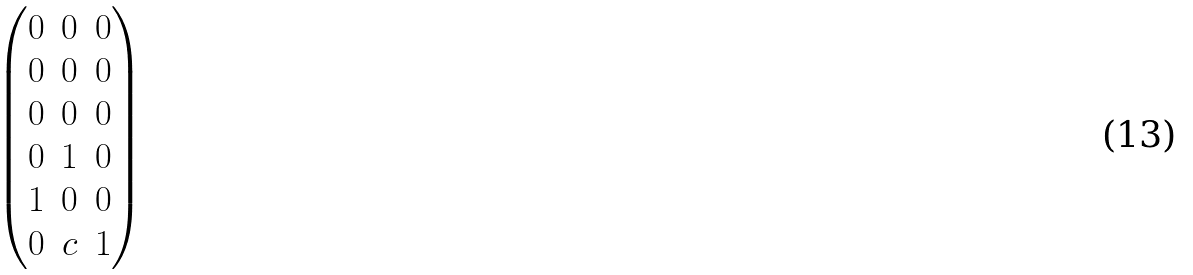<formula> <loc_0><loc_0><loc_500><loc_500>\begin{pmatrix} 0 & 0 & 0 \\ 0 & 0 & 0 \\ 0 & 0 & 0 \\ 0 & 1 & 0 \\ 1 & 0 & 0 \\ 0 & c & 1 \end{pmatrix}</formula> 